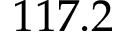Convert formula to latex. <formula><loc_0><loc_0><loc_500><loc_500>1 1 7 . 2</formula> 